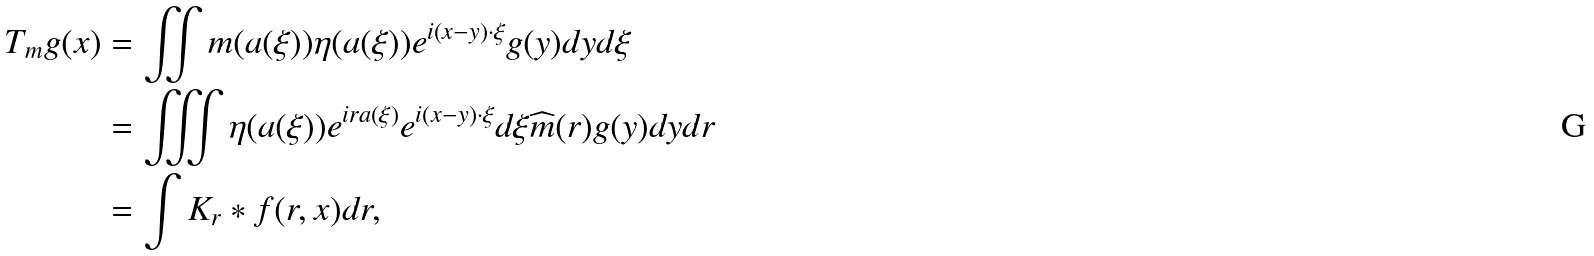Convert formula to latex. <formula><loc_0><loc_0><loc_500><loc_500>T _ { m } g ( x ) & = \iint m ( a ( \xi ) ) \eta ( a ( \xi ) ) e ^ { i ( x - y ) \cdot \xi } g ( y ) d y d \xi \\ & = \iiint \eta ( a ( \xi ) ) e ^ { i r a ( \xi ) } e ^ { i ( x - y ) \cdot \xi } d \xi \widehat { m } ( r ) g ( y ) d y d r \\ & = \int K _ { r } * f ( r , x ) d r ,</formula> 